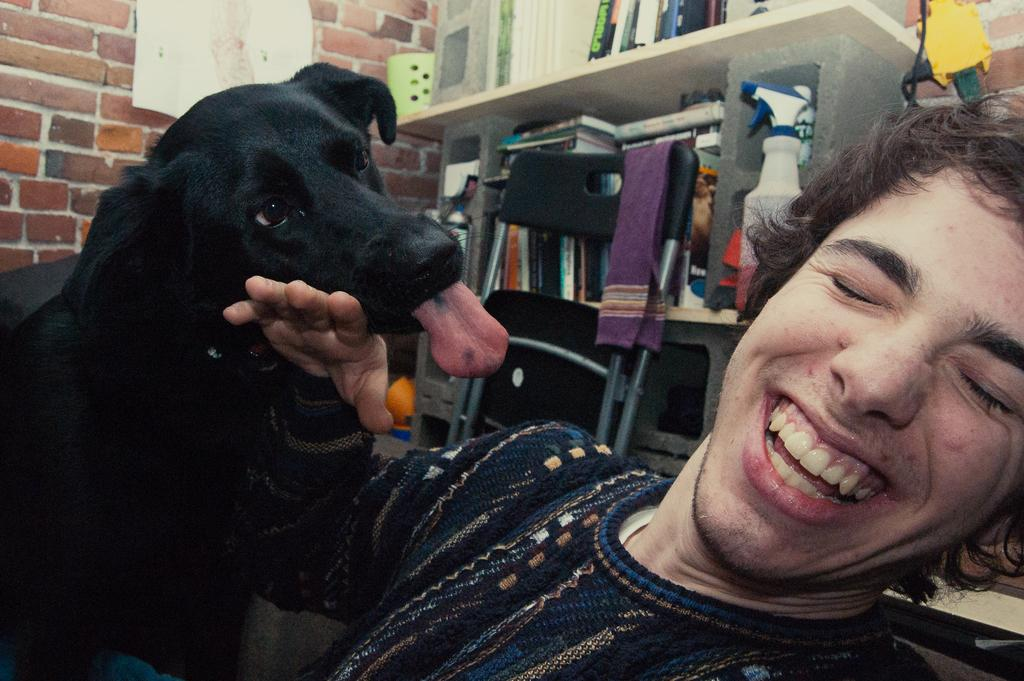Who is present in the image? There is a man in the image. What is the man doing in the image? The man is smiling in the image. What animal is beside the man? There is a dog beside the man. What can be seen in the background of the image? There are books in the background of the image. Where are the books located in the image? The books are kept on a shelf in the image. How does the wind affect the man and the dog in the image? There is no mention of wind in the image, so we cannot determine its effect on the man and the dog. 